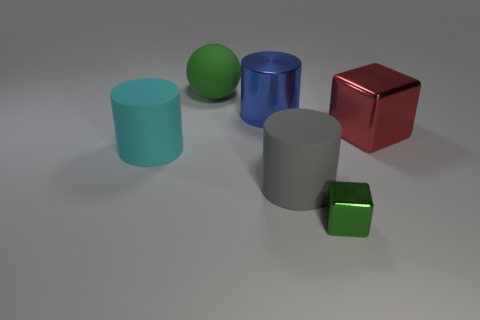Are there the same number of large spheres behind the cyan cylinder and large red metallic objects?
Ensure brevity in your answer.  Yes. How many other objects are there of the same material as the gray cylinder?
Ensure brevity in your answer.  2. There is a rubber cylinder to the right of the large cyan object; does it have the same size as the rubber cylinder that is left of the big green object?
Offer a very short reply. Yes. What number of objects are big things that are behind the big red shiny cube or matte things that are in front of the large red cube?
Your response must be concise. 4. Are there any other things that are the same shape as the large cyan thing?
Your answer should be very brief. Yes. There is a big cylinder that is left of the blue metallic cylinder; is its color the same as the large matte cylinder that is in front of the cyan cylinder?
Offer a very short reply. No. What number of matte things are either big gray things or blocks?
Your answer should be compact. 1. Are there any other things that are the same size as the green rubber sphere?
Keep it short and to the point. Yes. What shape is the large rubber object behind the big red shiny block on the right side of the green matte thing?
Ensure brevity in your answer.  Sphere. Does the green thing left of the tiny green metal block have the same material as the large cylinder that is to the left of the metal cylinder?
Your answer should be compact. Yes. 